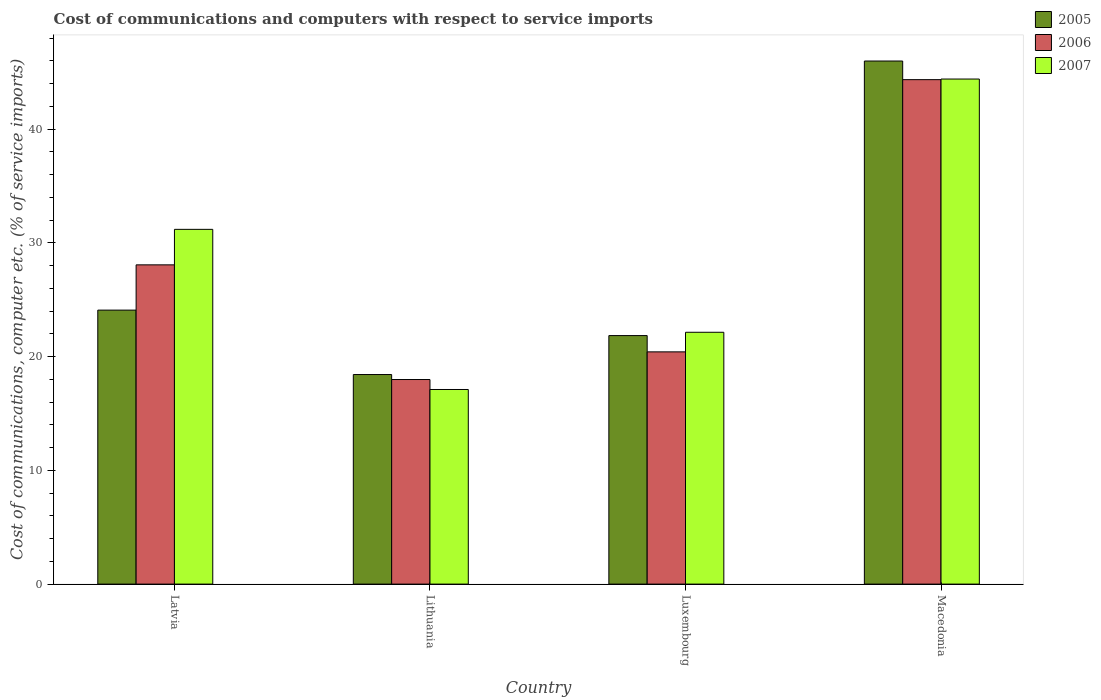Are the number of bars per tick equal to the number of legend labels?
Provide a short and direct response. Yes. Are the number of bars on each tick of the X-axis equal?
Provide a short and direct response. Yes. What is the label of the 1st group of bars from the left?
Provide a short and direct response. Latvia. What is the cost of communications and computers in 2006 in Latvia?
Make the answer very short. 28.07. Across all countries, what is the maximum cost of communications and computers in 2007?
Ensure brevity in your answer.  44.41. Across all countries, what is the minimum cost of communications and computers in 2007?
Offer a terse response. 17.11. In which country was the cost of communications and computers in 2006 maximum?
Ensure brevity in your answer.  Macedonia. In which country was the cost of communications and computers in 2007 minimum?
Offer a very short reply. Lithuania. What is the total cost of communications and computers in 2005 in the graph?
Provide a succinct answer. 110.36. What is the difference between the cost of communications and computers in 2005 in Lithuania and that in Macedonia?
Offer a terse response. -27.56. What is the difference between the cost of communications and computers in 2006 in Luxembourg and the cost of communications and computers in 2007 in Latvia?
Ensure brevity in your answer.  -10.77. What is the average cost of communications and computers in 2007 per country?
Make the answer very short. 28.71. What is the difference between the cost of communications and computers of/in 2005 and cost of communications and computers of/in 2006 in Macedonia?
Give a very brief answer. 1.64. In how many countries, is the cost of communications and computers in 2006 greater than 14 %?
Offer a very short reply. 4. What is the ratio of the cost of communications and computers in 2006 in Latvia to that in Luxembourg?
Give a very brief answer. 1.37. Is the difference between the cost of communications and computers in 2005 in Luxembourg and Macedonia greater than the difference between the cost of communications and computers in 2006 in Luxembourg and Macedonia?
Keep it short and to the point. No. What is the difference between the highest and the second highest cost of communications and computers in 2005?
Your response must be concise. 2.24. What is the difference between the highest and the lowest cost of communications and computers in 2005?
Offer a terse response. 27.56. In how many countries, is the cost of communications and computers in 2007 greater than the average cost of communications and computers in 2007 taken over all countries?
Your answer should be compact. 2. Is the sum of the cost of communications and computers in 2007 in Latvia and Lithuania greater than the maximum cost of communications and computers in 2006 across all countries?
Make the answer very short. Yes. What does the 2nd bar from the left in Lithuania represents?
Offer a terse response. 2006. What does the 2nd bar from the right in Latvia represents?
Ensure brevity in your answer.  2006. Is it the case that in every country, the sum of the cost of communications and computers in 2007 and cost of communications and computers in 2006 is greater than the cost of communications and computers in 2005?
Offer a very short reply. Yes. How many bars are there?
Give a very brief answer. 12. How many countries are there in the graph?
Ensure brevity in your answer.  4. Does the graph contain any zero values?
Provide a short and direct response. No. How many legend labels are there?
Provide a succinct answer. 3. What is the title of the graph?
Offer a very short reply. Cost of communications and computers with respect to service imports. What is the label or title of the Y-axis?
Make the answer very short. Cost of communications, computer etc. (% of service imports). What is the Cost of communications, computer etc. (% of service imports) in 2005 in Latvia?
Your answer should be very brief. 24.09. What is the Cost of communications, computer etc. (% of service imports) in 2006 in Latvia?
Ensure brevity in your answer.  28.07. What is the Cost of communications, computer etc. (% of service imports) in 2007 in Latvia?
Ensure brevity in your answer.  31.19. What is the Cost of communications, computer etc. (% of service imports) in 2005 in Lithuania?
Offer a very short reply. 18.43. What is the Cost of communications, computer etc. (% of service imports) of 2006 in Lithuania?
Your answer should be compact. 17.99. What is the Cost of communications, computer etc. (% of service imports) in 2007 in Lithuania?
Your response must be concise. 17.11. What is the Cost of communications, computer etc. (% of service imports) in 2005 in Luxembourg?
Offer a very short reply. 21.85. What is the Cost of communications, computer etc. (% of service imports) in 2006 in Luxembourg?
Ensure brevity in your answer.  20.42. What is the Cost of communications, computer etc. (% of service imports) in 2007 in Luxembourg?
Your answer should be very brief. 22.14. What is the Cost of communications, computer etc. (% of service imports) in 2005 in Macedonia?
Provide a short and direct response. 45.99. What is the Cost of communications, computer etc. (% of service imports) of 2006 in Macedonia?
Give a very brief answer. 44.35. What is the Cost of communications, computer etc. (% of service imports) of 2007 in Macedonia?
Your answer should be very brief. 44.41. Across all countries, what is the maximum Cost of communications, computer etc. (% of service imports) in 2005?
Keep it short and to the point. 45.99. Across all countries, what is the maximum Cost of communications, computer etc. (% of service imports) in 2006?
Offer a terse response. 44.35. Across all countries, what is the maximum Cost of communications, computer etc. (% of service imports) in 2007?
Provide a short and direct response. 44.41. Across all countries, what is the minimum Cost of communications, computer etc. (% of service imports) of 2005?
Provide a short and direct response. 18.43. Across all countries, what is the minimum Cost of communications, computer etc. (% of service imports) of 2006?
Your answer should be compact. 17.99. Across all countries, what is the minimum Cost of communications, computer etc. (% of service imports) of 2007?
Your response must be concise. 17.11. What is the total Cost of communications, computer etc. (% of service imports) in 2005 in the graph?
Offer a very short reply. 110.36. What is the total Cost of communications, computer etc. (% of service imports) in 2006 in the graph?
Give a very brief answer. 110.83. What is the total Cost of communications, computer etc. (% of service imports) in 2007 in the graph?
Keep it short and to the point. 114.85. What is the difference between the Cost of communications, computer etc. (% of service imports) of 2005 in Latvia and that in Lithuania?
Offer a very short reply. 5.66. What is the difference between the Cost of communications, computer etc. (% of service imports) of 2006 in Latvia and that in Lithuania?
Make the answer very short. 10.08. What is the difference between the Cost of communications, computer etc. (% of service imports) in 2007 in Latvia and that in Lithuania?
Your response must be concise. 14.08. What is the difference between the Cost of communications, computer etc. (% of service imports) of 2005 in Latvia and that in Luxembourg?
Your answer should be very brief. 2.24. What is the difference between the Cost of communications, computer etc. (% of service imports) in 2006 in Latvia and that in Luxembourg?
Your answer should be very brief. 7.65. What is the difference between the Cost of communications, computer etc. (% of service imports) of 2007 in Latvia and that in Luxembourg?
Offer a very short reply. 9.05. What is the difference between the Cost of communications, computer etc. (% of service imports) in 2005 in Latvia and that in Macedonia?
Your response must be concise. -21.9. What is the difference between the Cost of communications, computer etc. (% of service imports) of 2006 in Latvia and that in Macedonia?
Your response must be concise. -16.28. What is the difference between the Cost of communications, computer etc. (% of service imports) in 2007 in Latvia and that in Macedonia?
Offer a very short reply. -13.22. What is the difference between the Cost of communications, computer etc. (% of service imports) of 2005 in Lithuania and that in Luxembourg?
Provide a succinct answer. -3.42. What is the difference between the Cost of communications, computer etc. (% of service imports) of 2006 in Lithuania and that in Luxembourg?
Give a very brief answer. -2.43. What is the difference between the Cost of communications, computer etc. (% of service imports) of 2007 in Lithuania and that in Luxembourg?
Your answer should be very brief. -5.03. What is the difference between the Cost of communications, computer etc. (% of service imports) in 2005 in Lithuania and that in Macedonia?
Give a very brief answer. -27.57. What is the difference between the Cost of communications, computer etc. (% of service imports) in 2006 in Lithuania and that in Macedonia?
Provide a succinct answer. -26.37. What is the difference between the Cost of communications, computer etc. (% of service imports) of 2007 in Lithuania and that in Macedonia?
Give a very brief answer. -27.3. What is the difference between the Cost of communications, computer etc. (% of service imports) in 2005 in Luxembourg and that in Macedonia?
Ensure brevity in your answer.  -24.14. What is the difference between the Cost of communications, computer etc. (% of service imports) in 2006 in Luxembourg and that in Macedonia?
Your response must be concise. -23.93. What is the difference between the Cost of communications, computer etc. (% of service imports) in 2007 in Luxembourg and that in Macedonia?
Give a very brief answer. -22.27. What is the difference between the Cost of communications, computer etc. (% of service imports) in 2005 in Latvia and the Cost of communications, computer etc. (% of service imports) in 2006 in Lithuania?
Offer a very short reply. 6.1. What is the difference between the Cost of communications, computer etc. (% of service imports) in 2005 in Latvia and the Cost of communications, computer etc. (% of service imports) in 2007 in Lithuania?
Make the answer very short. 6.98. What is the difference between the Cost of communications, computer etc. (% of service imports) in 2006 in Latvia and the Cost of communications, computer etc. (% of service imports) in 2007 in Lithuania?
Make the answer very short. 10.96. What is the difference between the Cost of communications, computer etc. (% of service imports) of 2005 in Latvia and the Cost of communications, computer etc. (% of service imports) of 2006 in Luxembourg?
Provide a short and direct response. 3.67. What is the difference between the Cost of communications, computer etc. (% of service imports) of 2005 in Latvia and the Cost of communications, computer etc. (% of service imports) of 2007 in Luxembourg?
Offer a terse response. 1.95. What is the difference between the Cost of communications, computer etc. (% of service imports) in 2006 in Latvia and the Cost of communications, computer etc. (% of service imports) in 2007 in Luxembourg?
Offer a very short reply. 5.93. What is the difference between the Cost of communications, computer etc. (% of service imports) in 2005 in Latvia and the Cost of communications, computer etc. (% of service imports) in 2006 in Macedonia?
Provide a succinct answer. -20.26. What is the difference between the Cost of communications, computer etc. (% of service imports) of 2005 in Latvia and the Cost of communications, computer etc. (% of service imports) of 2007 in Macedonia?
Your answer should be compact. -20.32. What is the difference between the Cost of communications, computer etc. (% of service imports) in 2006 in Latvia and the Cost of communications, computer etc. (% of service imports) in 2007 in Macedonia?
Keep it short and to the point. -16.34. What is the difference between the Cost of communications, computer etc. (% of service imports) of 2005 in Lithuania and the Cost of communications, computer etc. (% of service imports) of 2006 in Luxembourg?
Offer a terse response. -1.99. What is the difference between the Cost of communications, computer etc. (% of service imports) of 2005 in Lithuania and the Cost of communications, computer etc. (% of service imports) of 2007 in Luxembourg?
Give a very brief answer. -3.72. What is the difference between the Cost of communications, computer etc. (% of service imports) of 2006 in Lithuania and the Cost of communications, computer etc. (% of service imports) of 2007 in Luxembourg?
Provide a short and direct response. -4.15. What is the difference between the Cost of communications, computer etc. (% of service imports) in 2005 in Lithuania and the Cost of communications, computer etc. (% of service imports) in 2006 in Macedonia?
Provide a succinct answer. -25.93. What is the difference between the Cost of communications, computer etc. (% of service imports) in 2005 in Lithuania and the Cost of communications, computer etc. (% of service imports) in 2007 in Macedonia?
Keep it short and to the point. -25.98. What is the difference between the Cost of communications, computer etc. (% of service imports) in 2006 in Lithuania and the Cost of communications, computer etc. (% of service imports) in 2007 in Macedonia?
Your response must be concise. -26.42. What is the difference between the Cost of communications, computer etc. (% of service imports) in 2005 in Luxembourg and the Cost of communications, computer etc. (% of service imports) in 2006 in Macedonia?
Ensure brevity in your answer.  -22.5. What is the difference between the Cost of communications, computer etc. (% of service imports) of 2005 in Luxembourg and the Cost of communications, computer etc. (% of service imports) of 2007 in Macedonia?
Your response must be concise. -22.56. What is the difference between the Cost of communications, computer etc. (% of service imports) in 2006 in Luxembourg and the Cost of communications, computer etc. (% of service imports) in 2007 in Macedonia?
Ensure brevity in your answer.  -23.99. What is the average Cost of communications, computer etc. (% of service imports) in 2005 per country?
Make the answer very short. 27.59. What is the average Cost of communications, computer etc. (% of service imports) of 2006 per country?
Ensure brevity in your answer.  27.71. What is the average Cost of communications, computer etc. (% of service imports) of 2007 per country?
Provide a succinct answer. 28.71. What is the difference between the Cost of communications, computer etc. (% of service imports) in 2005 and Cost of communications, computer etc. (% of service imports) in 2006 in Latvia?
Keep it short and to the point. -3.98. What is the difference between the Cost of communications, computer etc. (% of service imports) of 2005 and Cost of communications, computer etc. (% of service imports) of 2007 in Latvia?
Your answer should be very brief. -7.1. What is the difference between the Cost of communications, computer etc. (% of service imports) of 2006 and Cost of communications, computer etc. (% of service imports) of 2007 in Latvia?
Your answer should be very brief. -3.12. What is the difference between the Cost of communications, computer etc. (% of service imports) of 2005 and Cost of communications, computer etc. (% of service imports) of 2006 in Lithuania?
Provide a short and direct response. 0.44. What is the difference between the Cost of communications, computer etc. (% of service imports) of 2005 and Cost of communications, computer etc. (% of service imports) of 2007 in Lithuania?
Give a very brief answer. 1.31. What is the difference between the Cost of communications, computer etc. (% of service imports) in 2006 and Cost of communications, computer etc. (% of service imports) in 2007 in Lithuania?
Ensure brevity in your answer.  0.88. What is the difference between the Cost of communications, computer etc. (% of service imports) of 2005 and Cost of communications, computer etc. (% of service imports) of 2006 in Luxembourg?
Offer a terse response. 1.43. What is the difference between the Cost of communications, computer etc. (% of service imports) in 2005 and Cost of communications, computer etc. (% of service imports) in 2007 in Luxembourg?
Your response must be concise. -0.29. What is the difference between the Cost of communications, computer etc. (% of service imports) in 2006 and Cost of communications, computer etc. (% of service imports) in 2007 in Luxembourg?
Make the answer very short. -1.72. What is the difference between the Cost of communications, computer etc. (% of service imports) in 2005 and Cost of communications, computer etc. (% of service imports) in 2006 in Macedonia?
Provide a short and direct response. 1.64. What is the difference between the Cost of communications, computer etc. (% of service imports) in 2005 and Cost of communications, computer etc. (% of service imports) in 2007 in Macedonia?
Keep it short and to the point. 1.58. What is the difference between the Cost of communications, computer etc. (% of service imports) of 2006 and Cost of communications, computer etc. (% of service imports) of 2007 in Macedonia?
Provide a short and direct response. -0.05. What is the ratio of the Cost of communications, computer etc. (% of service imports) of 2005 in Latvia to that in Lithuania?
Offer a very short reply. 1.31. What is the ratio of the Cost of communications, computer etc. (% of service imports) of 2006 in Latvia to that in Lithuania?
Offer a very short reply. 1.56. What is the ratio of the Cost of communications, computer etc. (% of service imports) of 2007 in Latvia to that in Lithuania?
Offer a very short reply. 1.82. What is the ratio of the Cost of communications, computer etc. (% of service imports) of 2005 in Latvia to that in Luxembourg?
Offer a very short reply. 1.1. What is the ratio of the Cost of communications, computer etc. (% of service imports) in 2006 in Latvia to that in Luxembourg?
Provide a succinct answer. 1.37. What is the ratio of the Cost of communications, computer etc. (% of service imports) of 2007 in Latvia to that in Luxembourg?
Ensure brevity in your answer.  1.41. What is the ratio of the Cost of communications, computer etc. (% of service imports) of 2005 in Latvia to that in Macedonia?
Offer a very short reply. 0.52. What is the ratio of the Cost of communications, computer etc. (% of service imports) of 2006 in Latvia to that in Macedonia?
Provide a succinct answer. 0.63. What is the ratio of the Cost of communications, computer etc. (% of service imports) in 2007 in Latvia to that in Macedonia?
Your answer should be compact. 0.7. What is the ratio of the Cost of communications, computer etc. (% of service imports) in 2005 in Lithuania to that in Luxembourg?
Provide a succinct answer. 0.84. What is the ratio of the Cost of communications, computer etc. (% of service imports) of 2006 in Lithuania to that in Luxembourg?
Provide a short and direct response. 0.88. What is the ratio of the Cost of communications, computer etc. (% of service imports) of 2007 in Lithuania to that in Luxembourg?
Give a very brief answer. 0.77. What is the ratio of the Cost of communications, computer etc. (% of service imports) of 2005 in Lithuania to that in Macedonia?
Make the answer very short. 0.4. What is the ratio of the Cost of communications, computer etc. (% of service imports) in 2006 in Lithuania to that in Macedonia?
Make the answer very short. 0.41. What is the ratio of the Cost of communications, computer etc. (% of service imports) in 2007 in Lithuania to that in Macedonia?
Make the answer very short. 0.39. What is the ratio of the Cost of communications, computer etc. (% of service imports) in 2005 in Luxembourg to that in Macedonia?
Offer a very short reply. 0.48. What is the ratio of the Cost of communications, computer etc. (% of service imports) in 2006 in Luxembourg to that in Macedonia?
Make the answer very short. 0.46. What is the ratio of the Cost of communications, computer etc. (% of service imports) in 2007 in Luxembourg to that in Macedonia?
Offer a terse response. 0.5. What is the difference between the highest and the second highest Cost of communications, computer etc. (% of service imports) in 2005?
Provide a short and direct response. 21.9. What is the difference between the highest and the second highest Cost of communications, computer etc. (% of service imports) in 2006?
Provide a succinct answer. 16.28. What is the difference between the highest and the second highest Cost of communications, computer etc. (% of service imports) in 2007?
Your response must be concise. 13.22. What is the difference between the highest and the lowest Cost of communications, computer etc. (% of service imports) of 2005?
Give a very brief answer. 27.57. What is the difference between the highest and the lowest Cost of communications, computer etc. (% of service imports) of 2006?
Your answer should be very brief. 26.37. What is the difference between the highest and the lowest Cost of communications, computer etc. (% of service imports) of 2007?
Give a very brief answer. 27.3. 